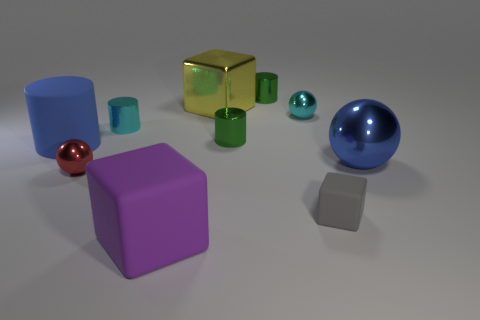Does the large shiny cube have the same color as the ball on the left side of the large yellow shiny cube? No, the large shiny cube is gold in color, whereas the ball on the left side of the large yellow cube is blue. 